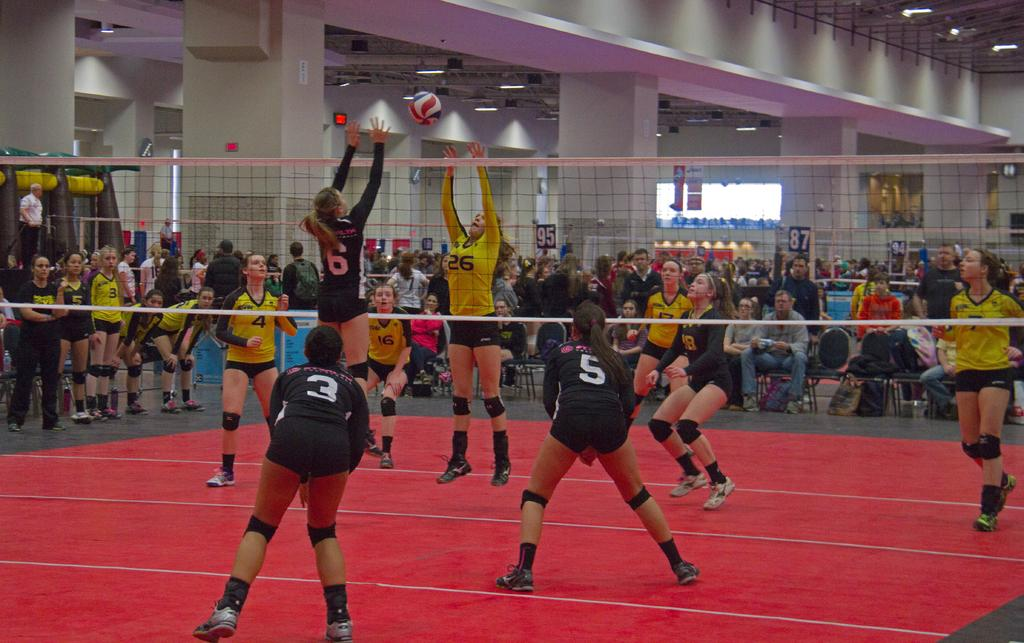What are the people in the image doing? There is a group of people sitting on chairs in the image. What sport-related object can be seen in the image? There is a netball in the image. Can you describe the people who are not sitting in the image? There are people standing in the image. What architectural features are visible in the background of the image? There are pillars visible in the background of the image. What other objects can be seen in the background of the image? There are lights and boards in the background of the image. What type of boot is being used to attack the netball in the image? There is no boot or attack present in the image; it features a group of people sitting on chairs and a netball. What record is being set by the people in the image? There is no record being set in the image; it simply shows a group of people sitting on chairs and a netball. 